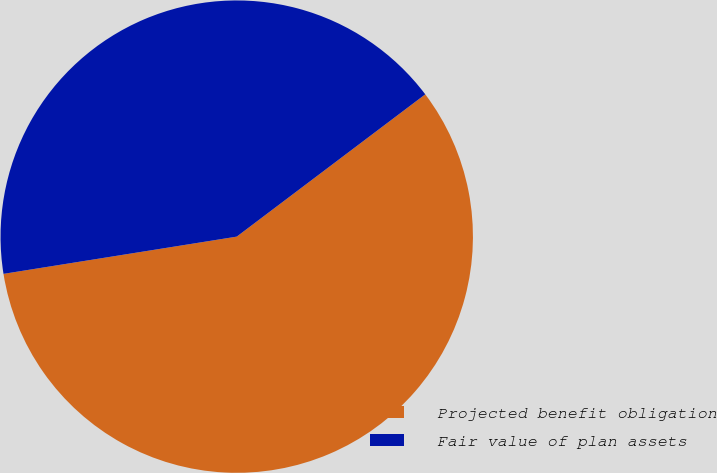Convert chart to OTSL. <chart><loc_0><loc_0><loc_500><loc_500><pie_chart><fcel>Projected benefit obligation<fcel>Fair value of plan assets<nl><fcel>57.77%<fcel>42.23%<nl></chart> 